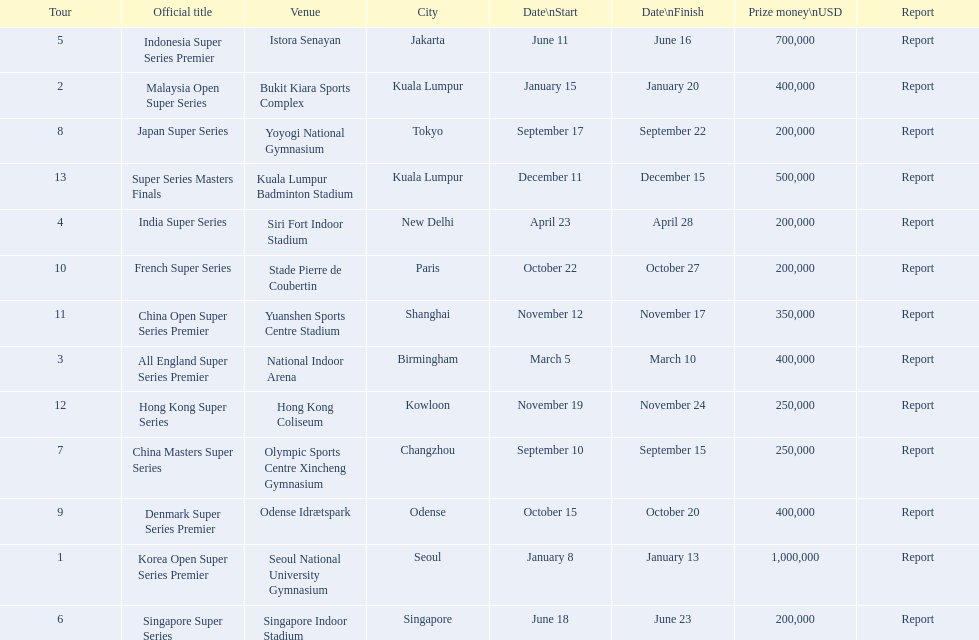Which series has the highest prize payout? Korea Open Super Series Premier. 